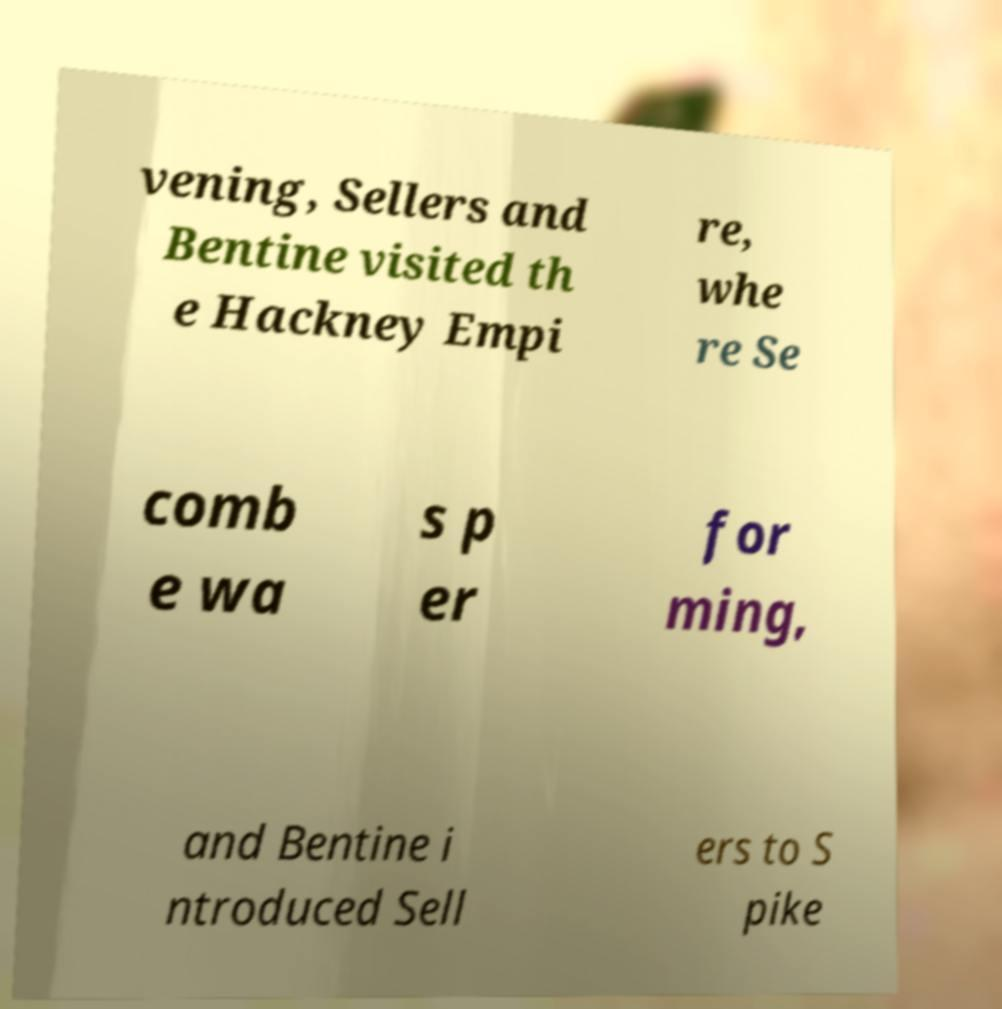Could you assist in decoding the text presented in this image and type it out clearly? vening, Sellers and Bentine visited th e Hackney Empi re, whe re Se comb e wa s p er for ming, and Bentine i ntroduced Sell ers to S pike 